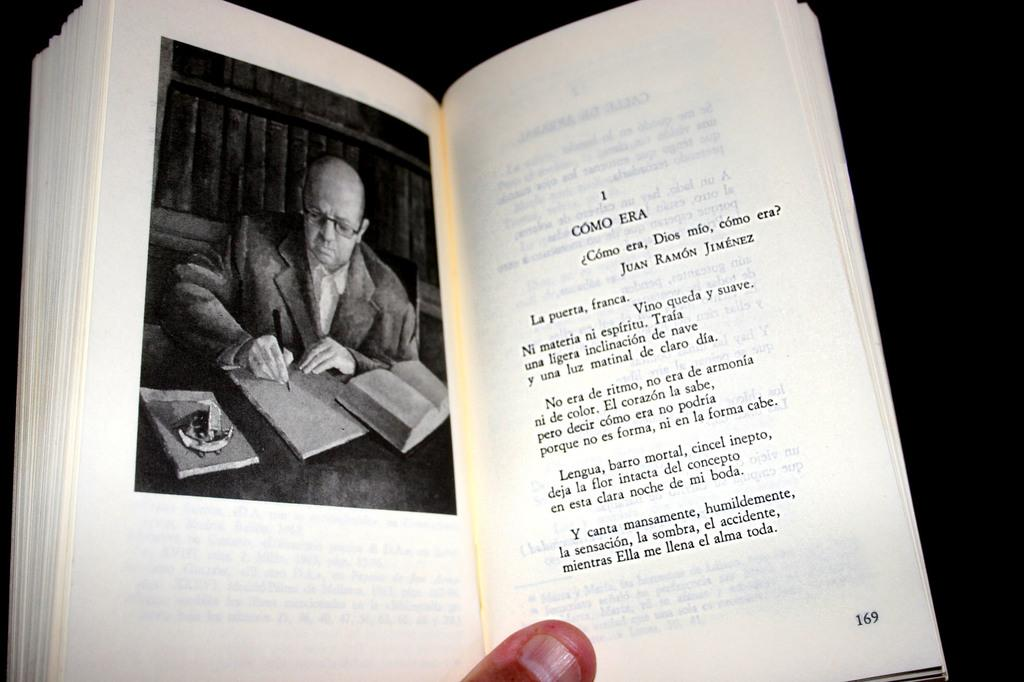<image>
Describe the image concisely. A book is open to page 169 and an image is shown as well. 